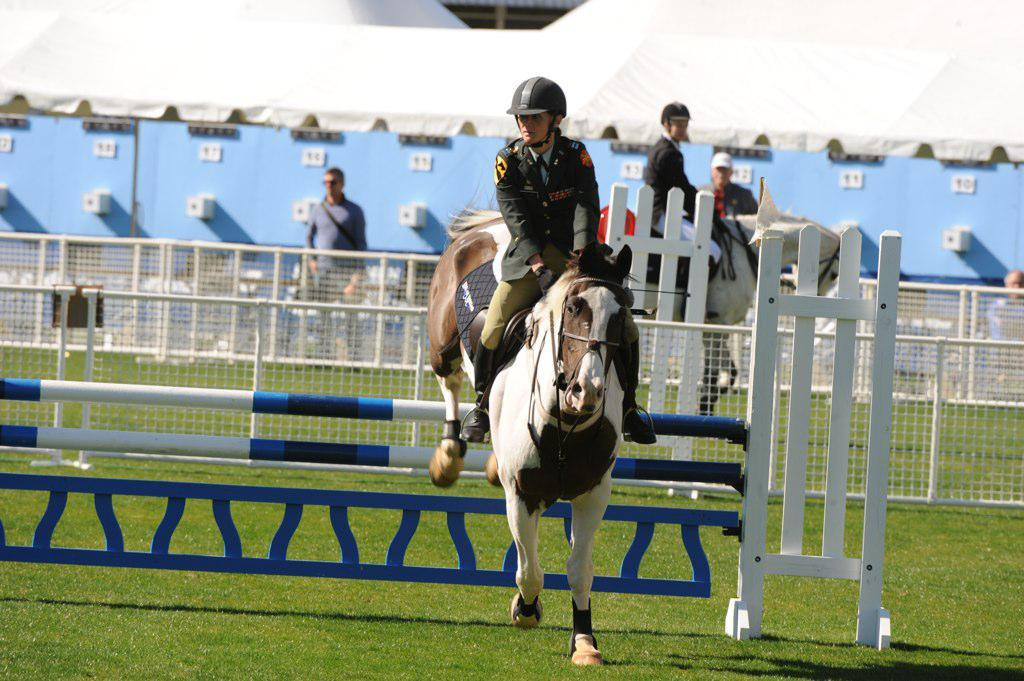Who or what can be seen in the image? There are people and horses in the image. What structures or objects are present in the image? There are railings, a tent, rods, and an object in the image. What is the terrain like in the image? The land is covered with grass. How many goldfish can be seen swimming in the grass in the image? There are no goldfish present in the image; the land is covered with grass, but no aquatic creatures are visible. 